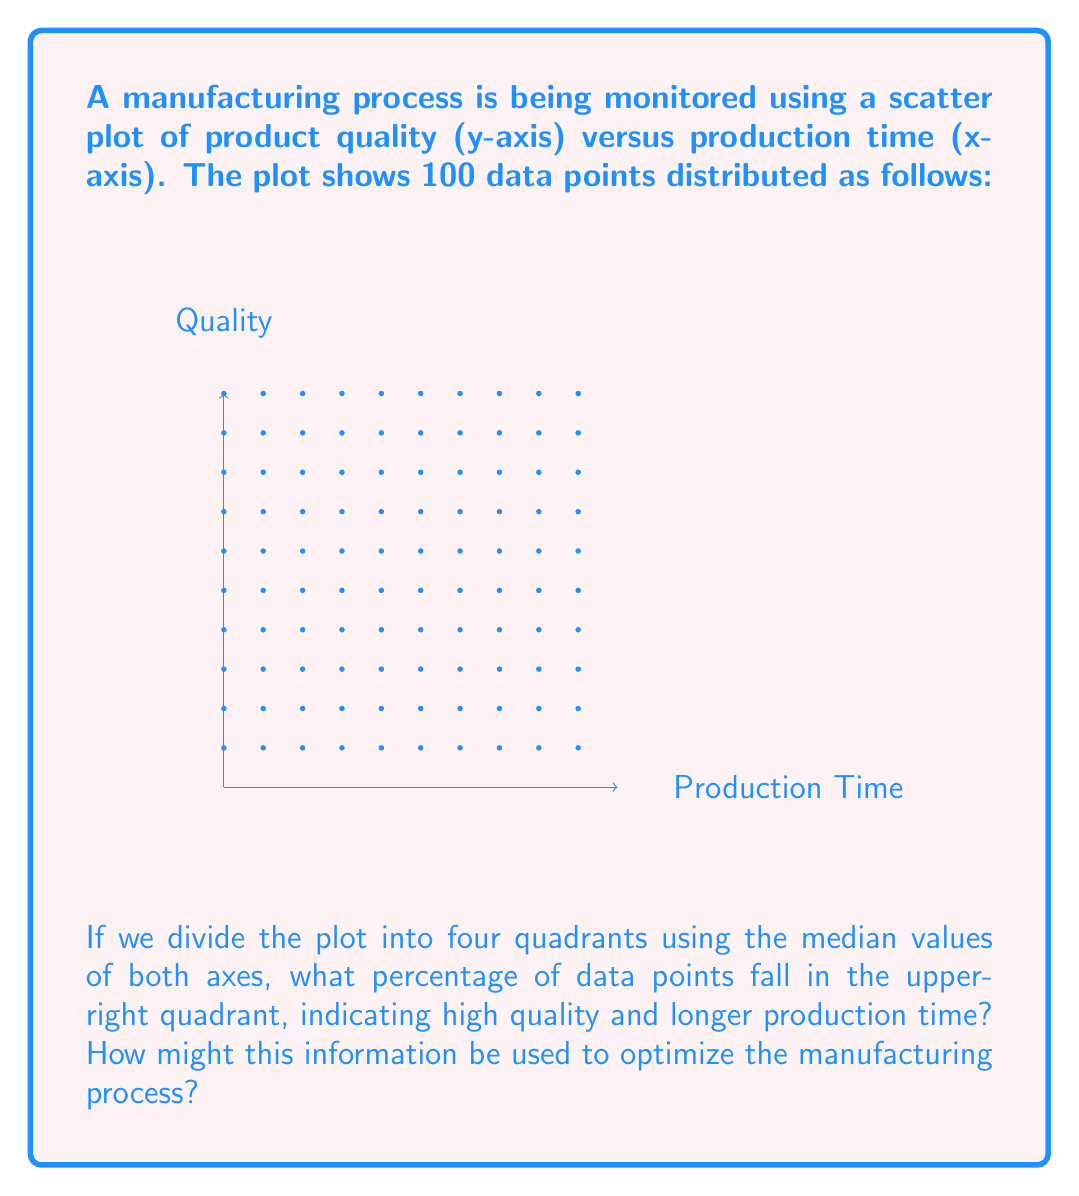Can you answer this question? To solve this problem, we need to follow these steps:

1. Identify the median values for both axes:
   - X-axis (Production Time): Median = (9 + 1) / 2 = 5
   - Y-axis (Quality): Median = (10 + 1) / 2 = 5.5

2. Count the data points in the upper-right quadrant:
   - This quadrant includes points with x > 5 and y > 5.5
   - There are 5 columns (6, 7, 8, 9, 10) and 4 rows (7, 8, 9, 10) in this quadrant
   - Total points in upper-right quadrant = 5 * 4 = 20

3. Calculate the percentage:
   - Total data points = 100
   - Percentage = (Points in upper-right quadrant / Total points) * 100
   - Percentage = (20 / 100) * 100 = 20%

4. Process optimization interpretation:
   - 20% of products have high quality but longer production time
   - This suggests a trade-off between quality and efficiency
   - To optimize the process, the operations manager could:
     a) Investigate why these products take longer to produce
     b) Determine if the higher quality justifies the longer production time
     c) Explore ways to maintain high quality while reducing production time
     d) Consider creating a premium product line if the higher quality is significantly better

By analyzing this spatial distribution, the operations manager can make data-driven decisions to balance quality and efficiency in the manufacturing process.
Answer: 20%; Investigate quality-time trade-off, optimize for efficiency while maintaining quality. 